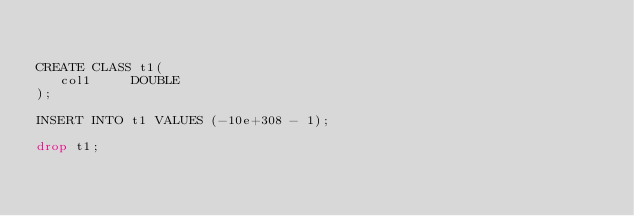<code> <loc_0><loc_0><loc_500><loc_500><_SQL_>

CREATE CLASS t1(
   col1     DOUBLE 
);

INSERT INTO t1 VALUES (-10e+308 - 1);

drop t1;</code> 